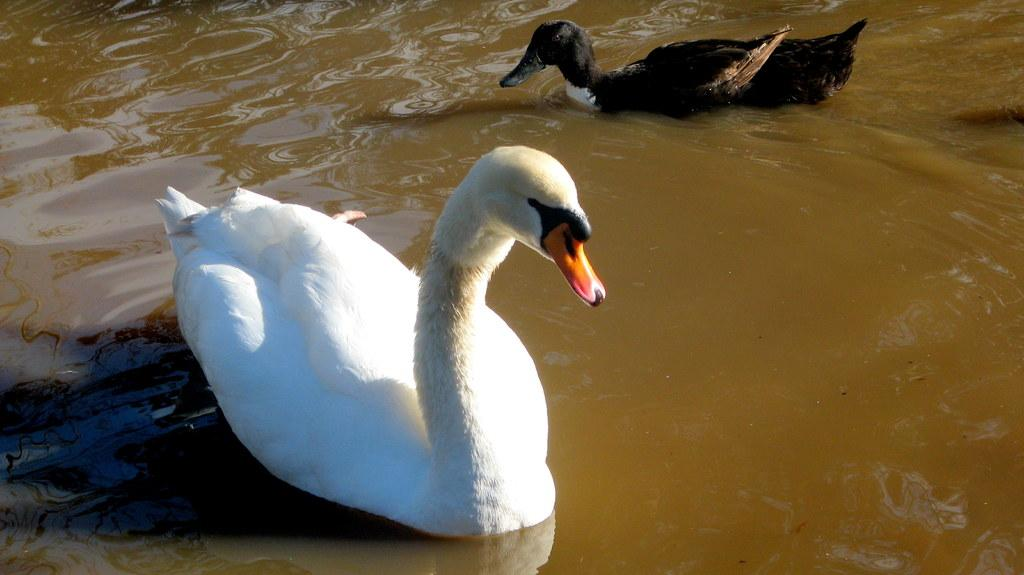What animals are present in the image? There are swans in the image. Where are the swans located? The swans are in the water. What type of pizzas are being served in the image? There are no pizzas present in the image; it features swans in the water. 